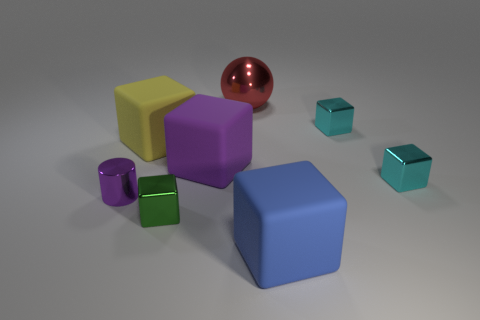Subtract all cyan cubes. How many cubes are left? 4 Subtract 2 blocks. How many blocks are left? 4 Subtract all purple matte cubes. How many cubes are left? 5 Subtract all purple blocks. Subtract all brown cylinders. How many blocks are left? 5 Add 1 small objects. How many objects exist? 9 Subtract all blocks. How many objects are left? 2 Add 3 small blocks. How many small blocks are left? 6 Add 1 large shiny spheres. How many large shiny spheres exist? 2 Subtract 0 green balls. How many objects are left? 8 Subtract all purple cubes. Subtract all metal balls. How many objects are left? 6 